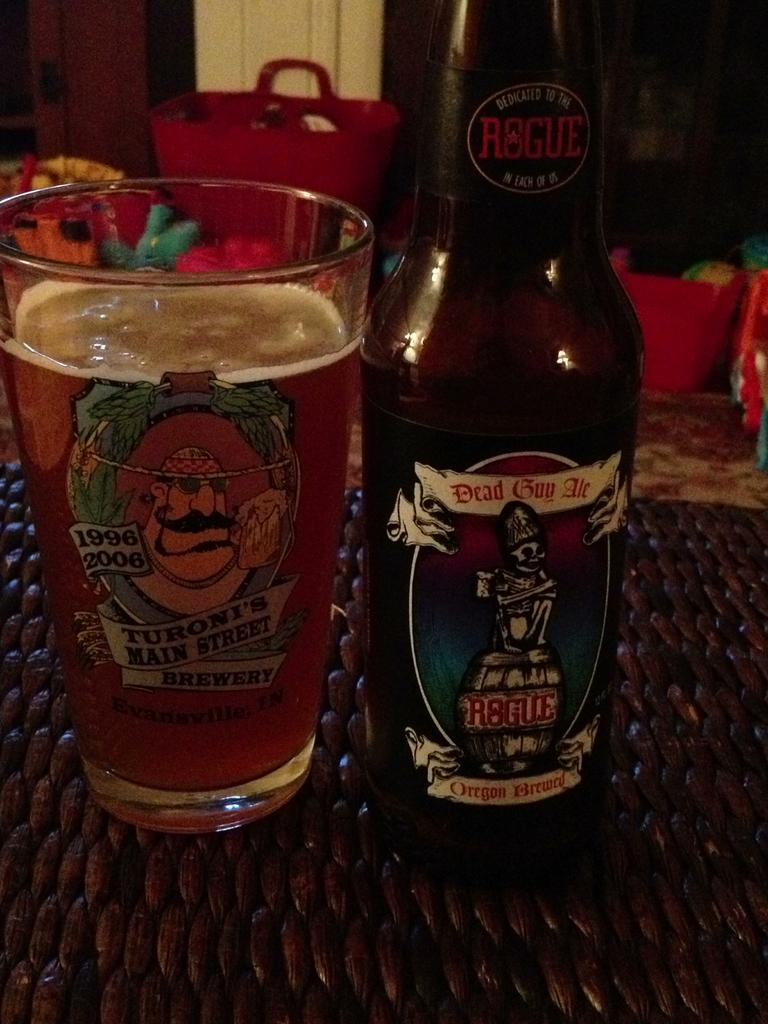<image>
Give a short and clear explanation of the subsequent image. A bottle of Dead Guy Ale sits beside a glass filled with liquid. 